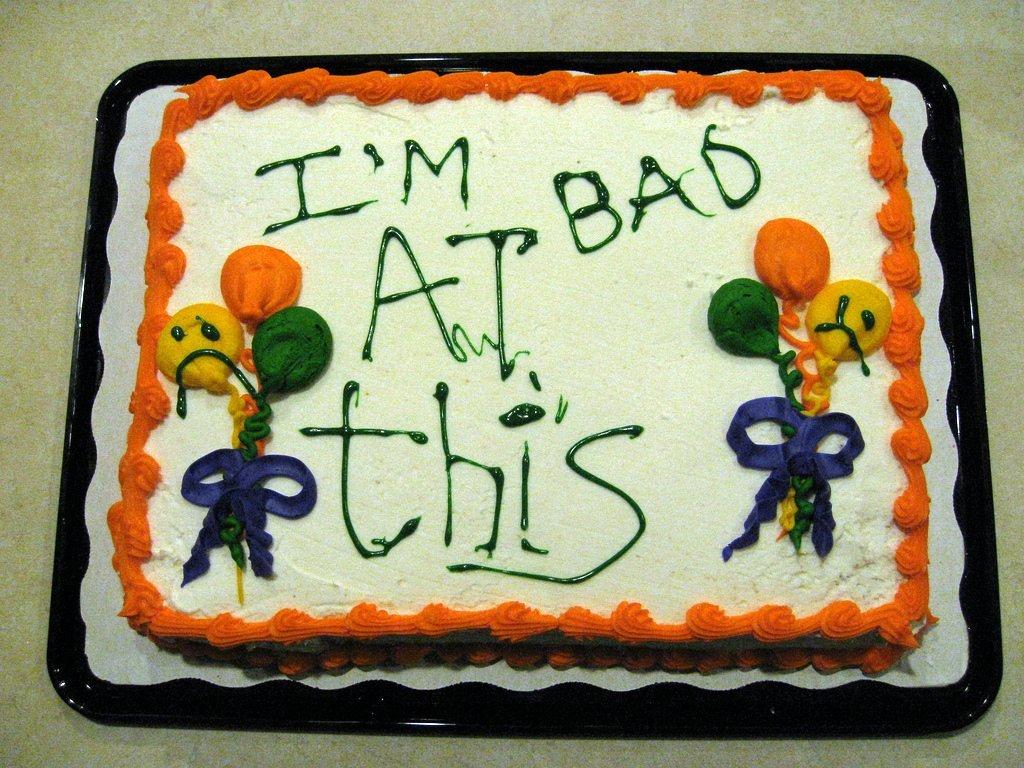What is the main subject of the image? The main subject of the image is a cake. How is the cake presented in the image? The cake is on a plate in the image. What design element is featured on the cake? The cake has cream in the design of balloons. What type of dress is the cake wearing in the image? There is no dress present in the image, as the subject is a cake. 